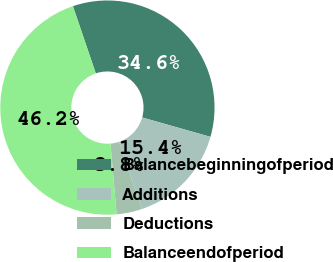Convert chart. <chart><loc_0><loc_0><loc_500><loc_500><pie_chart><fcel>Balancebeginningofperiod<fcel>Additions<fcel>Deductions<fcel>Balanceendofperiod<nl><fcel>34.62%<fcel>15.38%<fcel>3.85%<fcel>46.15%<nl></chart> 